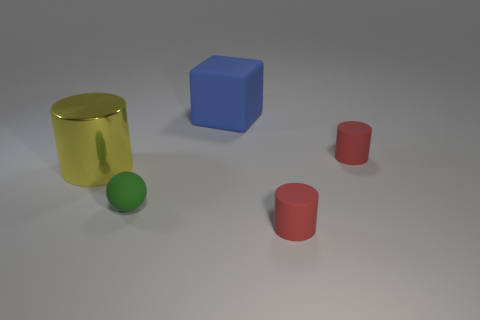What number of other things are there of the same size as the green matte ball? 2 